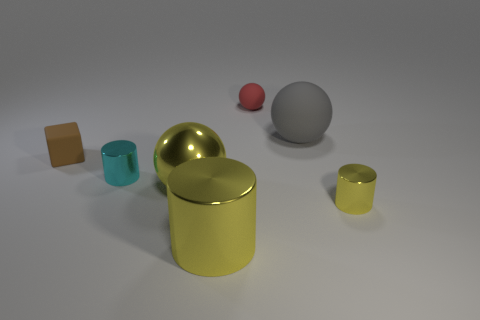Subtract all small metallic cylinders. How many cylinders are left? 1 Add 1 balls. How many objects exist? 8 Subtract all gray blocks. How many yellow cylinders are left? 2 Subtract 1 balls. How many balls are left? 2 Subtract all cyan cylinders. How many cylinders are left? 2 Add 1 brown matte spheres. How many brown matte spheres exist? 1 Subtract 0 purple cylinders. How many objects are left? 7 Subtract all spheres. How many objects are left? 4 Subtract all blue balls. Subtract all purple cylinders. How many balls are left? 3 Subtract all yellow rubber balls. Subtract all cyan metallic cylinders. How many objects are left? 6 